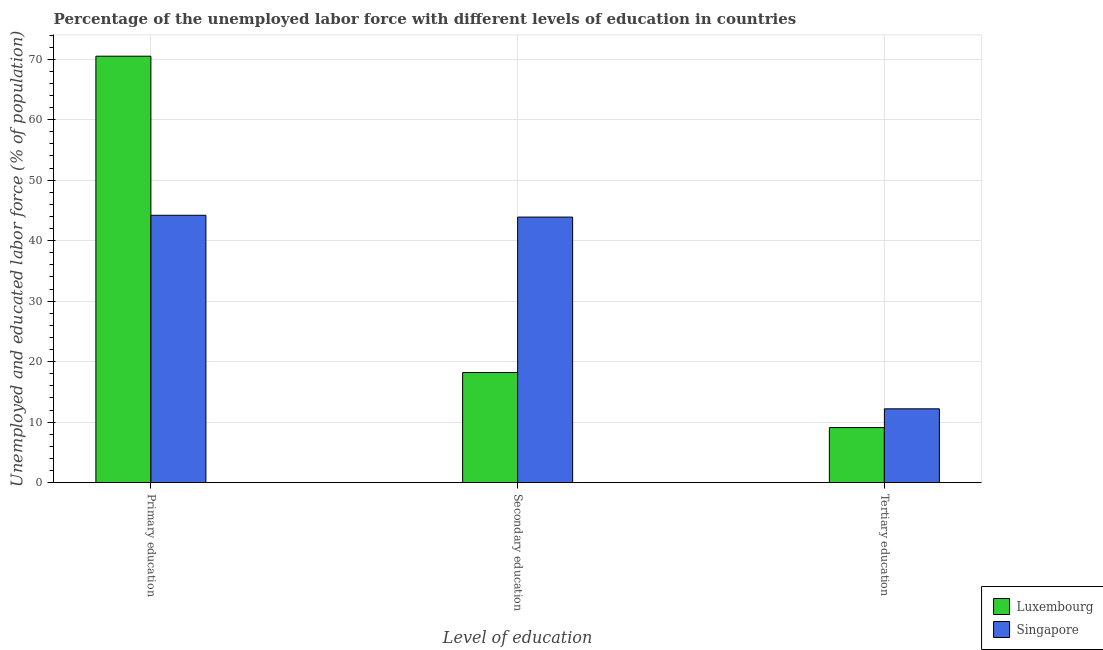Are the number of bars per tick equal to the number of legend labels?
Your answer should be compact. Yes. Are the number of bars on each tick of the X-axis equal?
Offer a terse response. Yes. What is the label of the 2nd group of bars from the left?
Your response must be concise. Secondary education. What is the percentage of labor force who received tertiary education in Singapore?
Give a very brief answer. 12.2. Across all countries, what is the maximum percentage of labor force who received primary education?
Provide a succinct answer. 70.5. Across all countries, what is the minimum percentage of labor force who received secondary education?
Offer a very short reply. 18.2. In which country was the percentage of labor force who received primary education maximum?
Your response must be concise. Luxembourg. In which country was the percentage of labor force who received secondary education minimum?
Give a very brief answer. Luxembourg. What is the total percentage of labor force who received secondary education in the graph?
Your response must be concise. 62.1. What is the difference between the percentage of labor force who received secondary education in Singapore and that in Luxembourg?
Your response must be concise. 25.7. What is the difference between the percentage of labor force who received tertiary education in Luxembourg and the percentage of labor force who received primary education in Singapore?
Give a very brief answer. -35.1. What is the average percentage of labor force who received tertiary education per country?
Offer a terse response. 10.65. What is the difference between the percentage of labor force who received primary education and percentage of labor force who received tertiary education in Singapore?
Provide a short and direct response. 32. In how many countries, is the percentage of labor force who received tertiary education greater than 72 %?
Provide a short and direct response. 0. What is the ratio of the percentage of labor force who received secondary education in Luxembourg to that in Singapore?
Your answer should be very brief. 0.41. Is the percentage of labor force who received primary education in Singapore less than that in Luxembourg?
Make the answer very short. Yes. What is the difference between the highest and the second highest percentage of labor force who received tertiary education?
Provide a short and direct response. 3.1. What is the difference between the highest and the lowest percentage of labor force who received tertiary education?
Offer a very short reply. 3.1. What does the 2nd bar from the left in Primary education represents?
Ensure brevity in your answer.  Singapore. What does the 2nd bar from the right in Primary education represents?
Ensure brevity in your answer.  Luxembourg. How many bars are there?
Your response must be concise. 6. Does the graph contain any zero values?
Provide a short and direct response. No. Where does the legend appear in the graph?
Provide a short and direct response. Bottom right. How many legend labels are there?
Provide a succinct answer. 2. How are the legend labels stacked?
Provide a succinct answer. Vertical. What is the title of the graph?
Offer a terse response. Percentage of the unemployed labor force with different levels of education in countries. Does "Burkina Faso" appear as one of the legend labels in the graph?
Provide a succinct answer. No. What is the label or title of the X-axis?
Offer a terse response. Level of education. What is the label or title of the Y-axis?
Keep it short and to the point. Unemployed and educated labor force (% of population). What is the Unemployed and educated labor force (% of population) in Luxembourg in Primary education?
Your answer should be very brief. 70.5. What is the Unemployed and educated labor force (% of population) of Singapore in Primary education?
Your answer should be very brief. 44.2. What is the Unemployed and educated labor force (% of population) of Luxembourg in Secondary education?
Make the answer very short. 18.2. What is the Unemployed and educated labor force (% of population) of Singapore in Secondary education?
Your answer should be very brief. 43.9. What is the Unemployed and educated labor force (% of population) in Luxembourg in Tertiary education?
Keep it short and to the point. 9.1. What is the Unemployed and educated labor force (% of population) of Singapore in Tertiary education?
Your response must be concise. 12.2. Across all Level of education, what is the maximum Unemployed and educated labor force (% of population) in Luxembourg?
Make the answer very short. 70.5. Across all Level of education, what is the maximum Unemployed and educated labor force (% of population) in Singapore?
Ensure brevity in your answer.  44.2. Across all Level of education, what is the minimum Unemployed and educated labor force (% of population) in Luxembourg?
Give a very brief answer. 9.1. Across all Level of education, what is the minimum Unemployed and educated labor force (% of population) in Singapore?
Offer a terse response. 12.2. What is the total Unemployed and educated labor force (% of population) of Luxembourg in the graph?
Make the answer very short. 97.8. What is the total Unemployed and educated labor force (% of population) of Singapore in the graph?
Keep it short and to the point. 100.3. What is the difference between the Unemployed and educated labor force (% of population) in Luxembourg in Primary education and that in Secondary education?
Your response must be concise. 52.3. What is the difference between the Unemployed and educated labor force (% of population) in Luxembourg in Primary education and that in Tertiary education?
Your answer should be compact. 61.4. What is the difference between the Unemployed and educated labor force (% of population) in Luxembourg in Secondary education and that in Tertiary education?
Offer a terse response. 9.1. What is the difference between the Unemployed and educated labor force (% of population) in Singapore in Secondary education and that in Tertiary education?
Give a very brief answer. 31.7. What is the difference between the Unemployed and educated labor force (% of population) in Luxembourg in Primary education and the Unemployed and educated labor force (% of population) in Singapore in Secondary education?
Your response must be concise. 26.6. What is the difference between the Unemployed and educated labor force (% of population) of Luxembourg in Primary education and the Unemployed and educated labor force (% of population) of Singapore in Tertiary education?
Offer a terse response. 58.3. What is the difference between the Unemployed and educated labor force (% of population) of Luxembourg in Secondary education and the Unemployed and educated labor force (% of population) of Singapore in Tertiary education?
Provide a short and direct response. 6. What is the average Unemployed and educated labor force (% of population) of Luxembourg per Level of education?
Your response must be concise. 32.6. What is the average Unemployed and educated labor force (% of population) in Singapore per Level of education?
Provide a succinct answer. 33.43. What is the difference between the Unemployed and educated labor force (% of population) of Luxembourg and Unemployed and educated labor force (% of population) of Singapore in Primary education?
Make the answer very short. 26.3. What is the difference between the Unemployed and educated labor force (% of population) in Luxembourg and Unemployed and educated labor force (% of population) in Singapore in Secondary education?
Offer a very short reply. -25.7. What is the difference between the Unemployed and educated labor force (% of population) in Luxembourg and Unemployed and educated labor force (% of population) in Singapore in Tertiary education?
Give a very brief answer. -3.1. What is the ratio of the Unemployed and educated labor force (% of population) in Luxembourg in Primary education to that in Secondary education?
Offer a very short reply. 3.87. What is the ratio of the Unemployed and educated labor force (% of population) in Singapore in Primary education to that in Secondary education?
Provide a short and direct response. 1.01. What is the ratio of the Unemployed and educated labor force (% of population) of Luxembourg in Primary education to that in Tertiary education?
Provide a short and direct response. 7.75. What is the ratio of the Unemployed and educated labor force (% of population) of Singapore in Primary education to that in Tertiary education?
Make the answer very short. 3.62. What is the ratio of the Unemployed and educated labor force (% of population) of Luxembourg in Secondary education to that in Tertiary education?
Provide a succinct answer. 2. What is the ratio of the Unemployed and educated labor force (% of population) in Singapore in Secondary education to that in Tertiary education?
Keep it short and to the point. 3.6. What is the difference between the highest and the second highest Unemployed and educated labor force (% of population) of Luxembourg?
Provide a short and direct response. 52.3. What is the difference between the highest and the second highest Unemployed and educated labor force (% of population) in Singapore?
Keep it short and to the point. 0.3. What is the difference between the highest and the lowest Unemployed and educated labor force (% of population) in Luxembourg?
Keep it short and to the point. 61.4. What is the difference between the highest and the lowest Unemployed and educated labor force (% of population) in Singapore?
Offer a terse response. 32. 